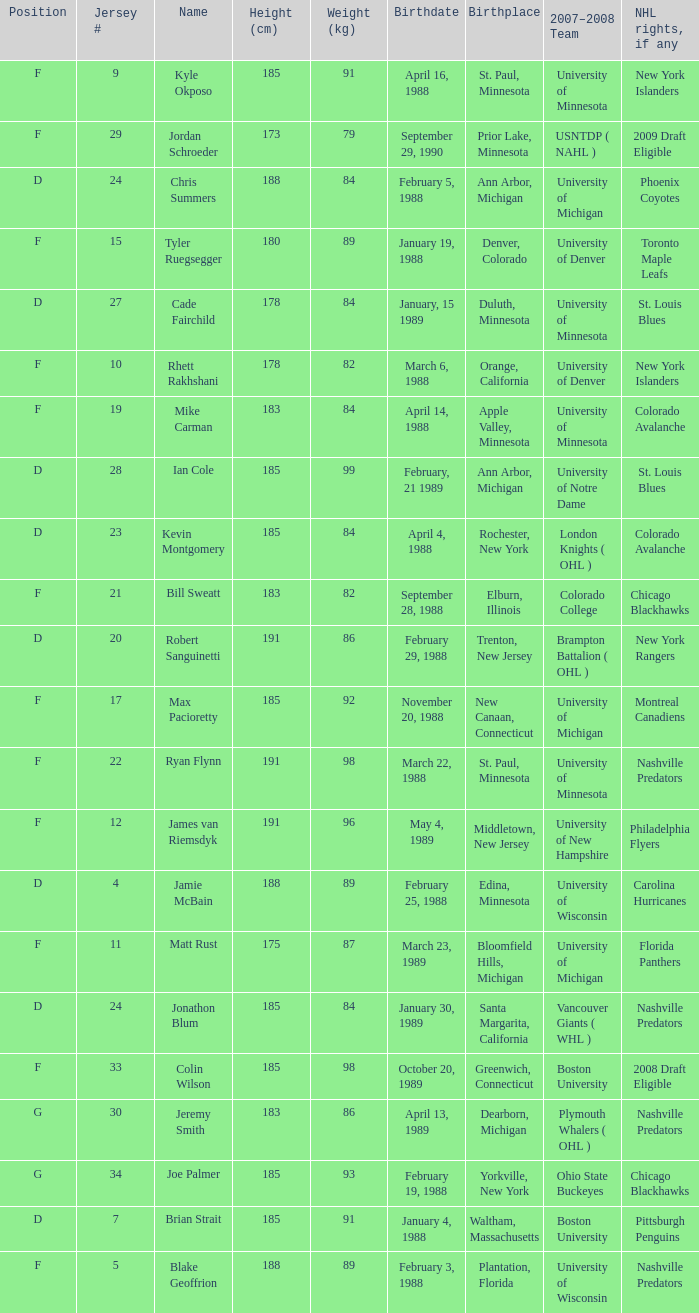Would you be able to parse every entry in this table? {'header': ['Position', 'Jersey #', 'Name', 'Height (cm)', 'Weight (kg)', 'Birthdate', 'Birthplace', '2007–2008 Team', 'NHL rights, if any'], 'rows': [['F', '9', 'Kyle Okposo', '185', '91', 'April 16, 1988', 'St. Paul, Minnesota', 'University of Minnesota', 'New York Islanders'], ['F', '29', 'Jordan Schroeder', '173', '79', 'September 29, 1990', 'Prior Lake, Minnesota', 'USNTDP ( NAHL )', '2009 Draft Eligible'], ['D', '24', 'Chris Summers', '188', '84', 'February 5, 1988', 'Ann Arbor, Michigan', 'University of Michigan', 'Phoenix Coyotes'], ['F', '15', 'Tyler Ruegsegger', '180', '89', 'January 19, 1988', 'Denver, Colorado', 'University of Denver', 'Toronto Maple Leafs'], ['D', '27', 'Cade Fairchild', '178', '84', 'January, 15 1989', 'Duluth, Minnesota', 'University of Minnesota', 'St. Louis Blues'], ['F', '10', 'Rhett Rakhshani', '178', '82', 'March 6, 1988', 'Orange, California', 'University of Denver', 'New York Islanders'], ['F', '19', 'Mike Carman', '183', '84', 'April 14, 1988', 'Apple Valley, Minnesota', 'University of Minnesota', 'Colorado Avalanche'], ['D', '28', 'Ian Cole', '185', '99', 'February, 21 1989', 'Ann Arbor, Michigan', 'University of Notre Dame', 'St. Louis Blues'], ['D', '23', 'Kevin Montgomery', '185', '84', 'April 4, 1988', 'Rochester, New York', 'London Knights ( OHL )', 'Colorado Avalanche'], ['F', '21', 'Bill Sweatt', '183', '82', 'September 28, 1988', 'Elburn, Illinois', 'Colorado College', 'Chicago Blackhawks'], ['D', '20', 'Robert Sanguinetti', '191', '86', 'February 29, 1988', 'Trenton, New Jersey', 'Brampton Battalion ( OHL )', 'New York Rangers'], ['F', '17', 'Max Pacioretty', '185', '92', 'November 20, 1988', 'New Canaan, Connecticut', 'University of Michigan', 'Montreal Canadiens'], ['F', '22', 'Ryan Flynn', '191', '98', 'March 22, 1988', 'St. Paul, Minnesota', 'University of Minnesota', 'Nashville Predators'], ['F', '12', 'James van Riemsdyk', '191', '96', 'May 4, 1989', 'Middletown, New Jersey', 'University of New Hampshire', 'Philadelphia Flyers'], ['D', '4', 'Jamie McBain', '188', '89', 'February 25, 1988', 'Edina, Minnesota', 'University of Wisconsin', 'Carolina Hurricanes'], ['F', '11', 'Matt Rust', '175', '87', 'March 23, 1989', 'Bloomfield Hills, Michigan', 'University of Michigan', 'Florida Panthers'], ['D', '24', 'Jonathon Blum', '185', '84', 'January 30, 1989', 'Santa Margarita, California', 'Vancouver Giants ( WHL )', 'Nashville Predators'], ['F', '33', 'Colin Wilson', '185', '98', 'October 20, 1989', 'Greenwich, Connecticut', 'Boston University', '2008 Draft Eligible'], ['G', '30', 'Jeremy Smith', '183', '86', 'April 13, 1989', 'Dearborn, Michigan', 'Plymouth Whalers ( OHL )', 'Nashville Predators'], ['G', '34', 'Joe Palmer', '185', '93', 'February 19, 1988', 'Yorkville, New York', 'Ohio State Buckeyes', 'Chicago Blackhawks'], ['D', '7', 'Brian Strait', '185', '91', 'January 4, 1988', 'Waltham, Massachusetts', 'Boston University', 'Pittsburgh Penguins'], ['F', '5', 'Blake Geoffrion', '188', '89', 'February 3, 1988', 'Plantation, Florida', 'University of Wisconsin', 'Nashville Predators']]} Which Height (cm) has a Birthplace of new canaan, connecticut? 1.0. 